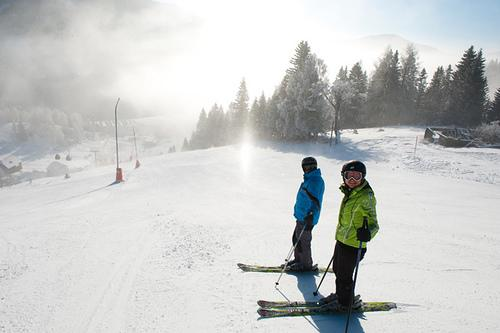Describe the weather conditions and landscape in the image. The image shows a snowy landscape with powdery white snow on the ground, snow-covered pine trees, mountains, and clouds rolling in above. Mention the different colors of skier's jackets present in the image. In the image, there are skiers in blue, yellow, bright green, and medium blue jackets. Name the key objects present in the slope scenery. Key objects include snow skis, skiers with ski poles, orange cones, metal pole, powdery snow slope, sun glare, and wooden lodging. Explain what the skiers in the image are wearing. The skiers are wearing colorful jackets, black pants, snow pants, ski helmets, and orange ski goggles while holding ski poles. What types of equipment are the skiers using in the image? The skiers are using snow skis, ski poles, ski helmets, and goggles. Mention two interesting aspects of the sun in the scene. The sun is shining behind the trees and there's a sun glare shining off the mountain. Mention a few objects found at the bottom of the slope. At the bottom of the slope, there are small wooden lodging, orange cones, and a small cabin. Provide a brief overview of the key elements in the image. Skiers in colorful jackets, snow-covered trees, mountains, sun behind trees, orange cones, houses, and ski poles can be seen in the image. Describe the trees in the image. There are pine trees covered in snow, snow-covered trees on the slope, and tall snow-covered pine trees. Describe the snow conditions in the image as if you were a skier. The snow is powdery white and clear, providing great conditions for skiing on the slope. 